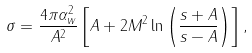Convert formula to latex. <formula><loc_0><loc_0><loc_500><loc_500>\sigma = \frac { 4 \pi \alpha _ { w } ^ { 2 } } { A ^ { 2 } } \left [ A + 2 M ^ { 2 } \ln \left ( \frac { { s } + A } { { s } - A } \right ) \right ] ,</formula> 